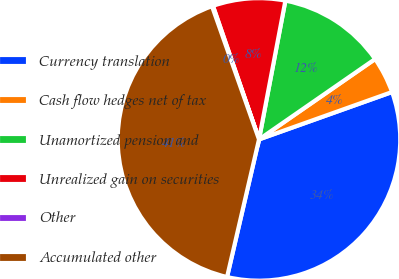Convert chart. <chart><loc_0><loc_0><loc_500><loc_500><pie_chart><fcel>Currency translation<fcel>Cash flow hedges net of tax<fcel>Unamortized pension and<fcel>Unrealized gain on securities<fcel>Other<fcel>Accumulated other<nl><fcel>34.08%<fcel>4.19%<fcel>12.37%<fcel>8.28%<fcel>0.11%<fcel>40.97%<nl></chart> 